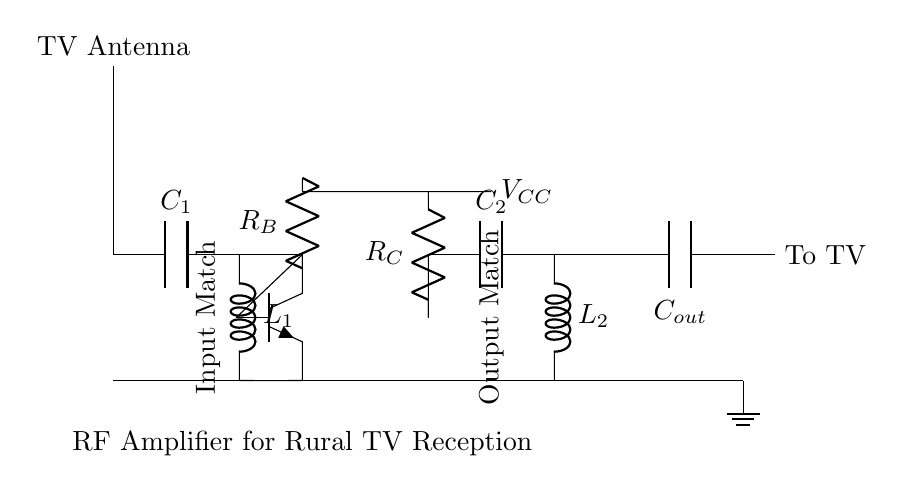What component is used for input matching? The input matching network consists of a capacitor labeled C1 and an inductor labeled L1, which are connected to the input from the TV antenna.
Answer: C1, L1 What type of transistor is used in the circuit? The circuit uses an NPN transistor, as indicated by the symbol and labeling in the diagram.
Answer: NPN How many resistors are in the circuit? The circuit contains two resistors labeled R_B and R_C, which are part of the transistor biasing and output stages.
Answer: 2 What is the typical value of V_CC in this circuit? While the actual value isn’t specified in the diagram, V_CC usually represents the supply voltage needed for the transistor operation; common values are often 5V, 9V, or 12V.
Answer: Not specified What is the purpose of the capacitor labeled C_out? The capacitor labeled C_out is intended to block DC voltage while allowing RF signals to pass through, thus coupling the amplified RF signal to the TV.
Answer: To couple RF signal What connections are indicated to ground? The ground connection is shown as a node at the bottom of the circuit, where the output, input matching components, and the transistor's emitter are linked to the ground.
Answer: Common ground What do L1 and L2 represent in this circuit? Inductors L1 and L2 are used for matching the impedance at the input and output stages of the amplifier, ensuring efficient signal transfer and amplification.
Answer: Inductors for matching 